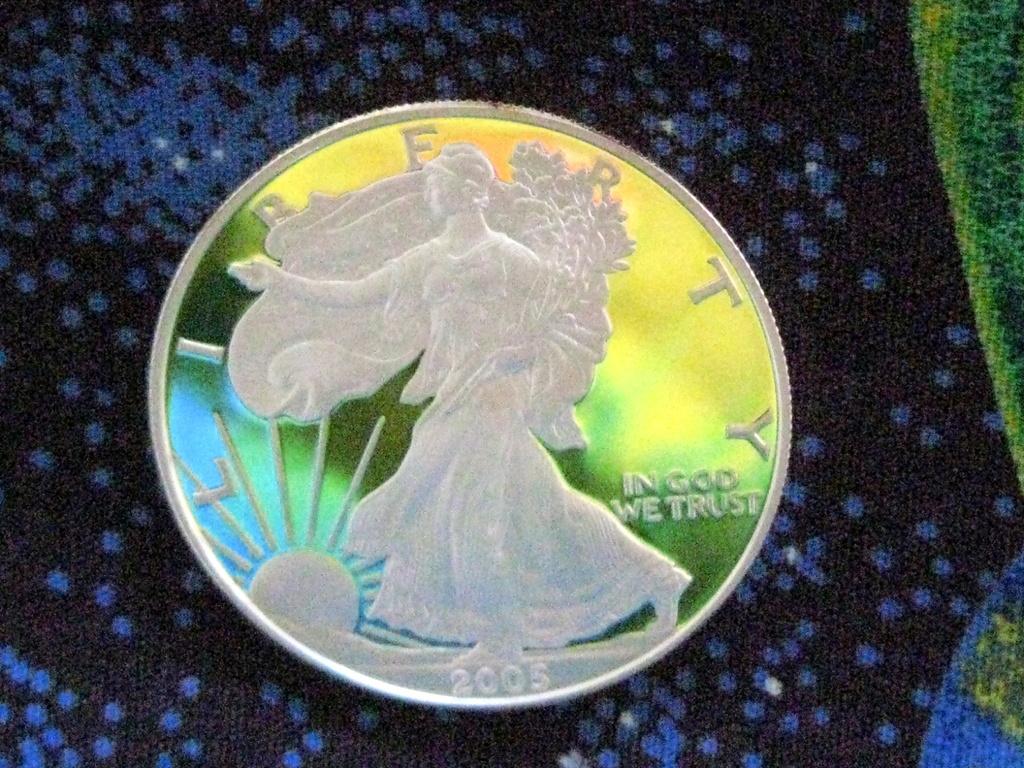What is written on this coin?
Provide a succinct answer. In god we trust. What year is imprinted on this coin?
Offer a terse response. 2005. 